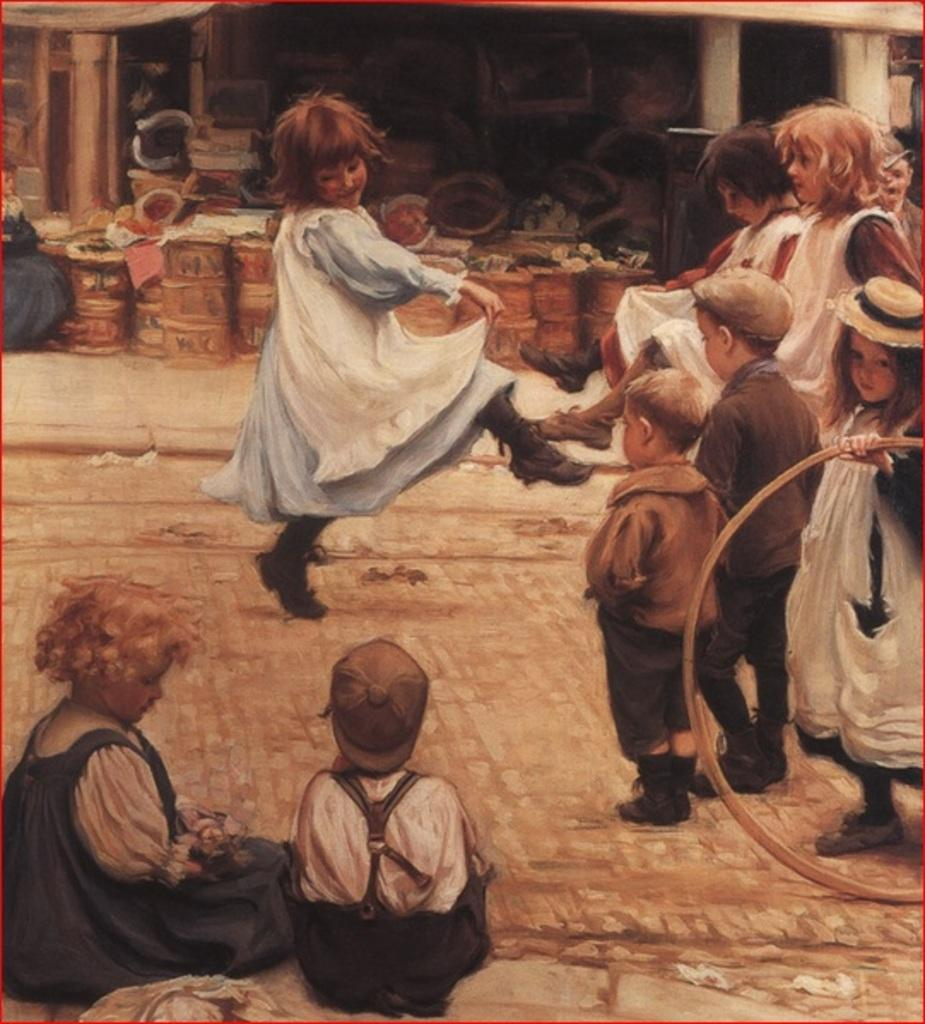What is the main subject of the image? The image contains a painting. What is happening in the painting? The painting depicts a group of children on the ground. Can you describe any specific actions or objects in the painting? One child in the painting is holding a ring, and there are drums present in the painting. What type of copper material can be seen in the painting? There is no copper material present in the painting; it features a group of children and various objects, but none of them are made of copper. 